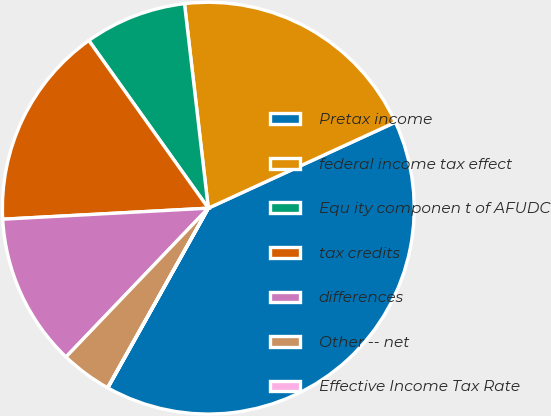<chart> <loc_0><loc_0><loc_500><loc_500><pie_chart><fcel>Pretax income<fcel>federal income tax effect<fcel>Equ ity componen t of AFUDC<fcel>tax credits<fcel>differences<fcel>Other -- net<fcel>Effective Income Tax Rate<nl><fcel>39.97%<fcel>19.99%<fcel>8.01%<fcel>16.0%<fcel>12.0%<fcel>4.01%<fcel>0.02%<nl></chart> 